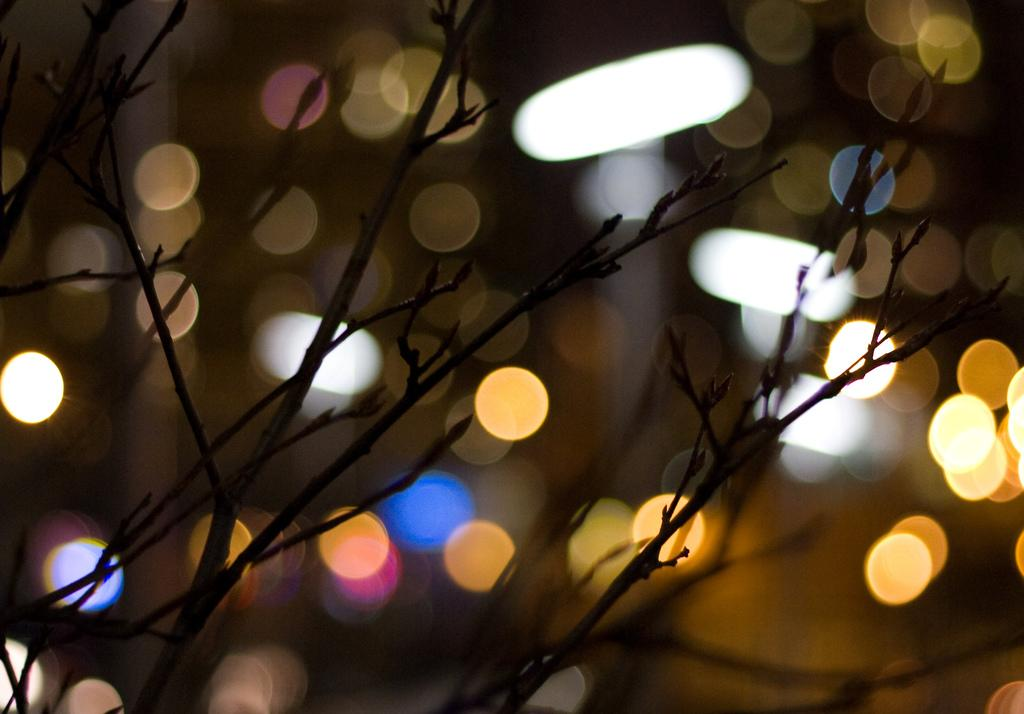What type of plant is in the image? There is a dried plant in the image. What else can be seen in the image besides the plant? There are colorful lights in the image. How many toys are scattered around the dried plant in the image? There are no toys present in the image; it only features a dried plant and colorful lights. 